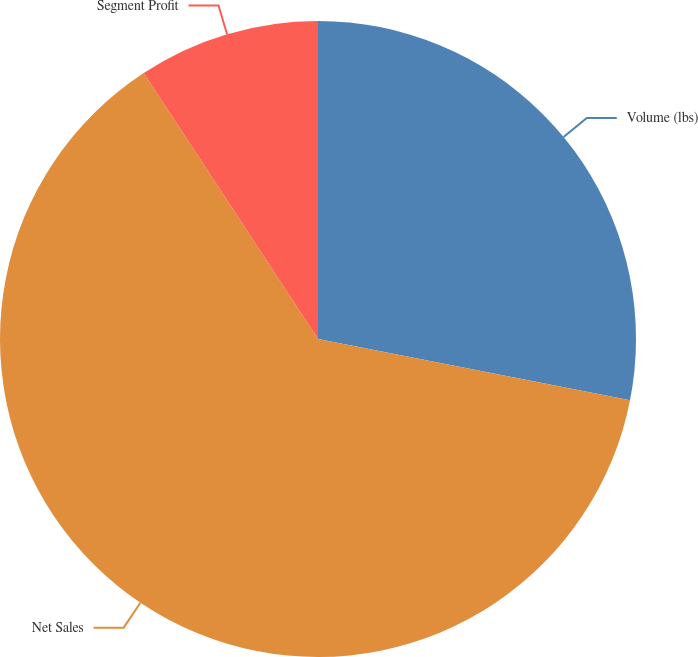Convert chart. <chart><loc_0><loc_0><loc_500><loc_500><pie_chart><fcel>Volume (lbs)<fcel>Net Sales<fcel>Segment Profit<nl><fcel>28.09%<fcel>62.68%<fcel>9.23%<nl></chart> 